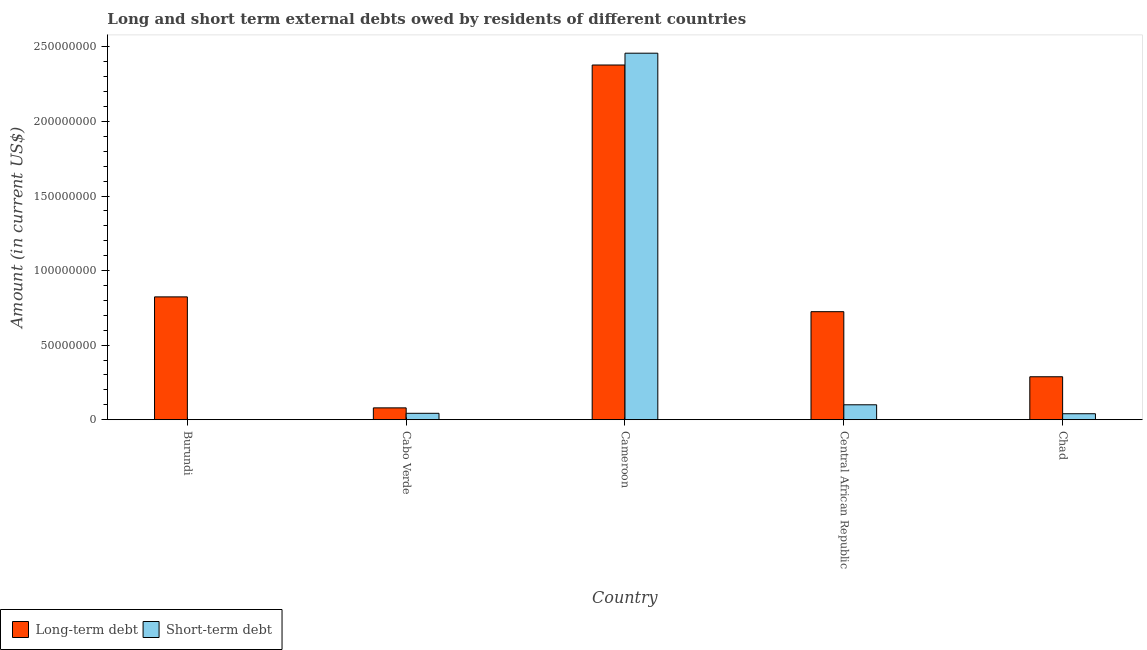How many different coloured bars are there?
Offer a terse response. 2. Are the number of bars on each tick of the X-axis equal?
Give a very brief answer. No. What is the label of the 5th group of bars from the left?
Provide a succinct answer. Chad. In how many cases, is the number of bars for a given country not equal to the number of legend labels?
Your response must be concise. 1. What is the long-term debts owed by residents in Chad?
Provide a short and direct response. 2.88e+07. Across all countries, what is the maximum long-term debts owed by residents?
Offer a very short reply. 2.38e+08. Across all countries, what is the minimum long-term debts owed by residents?
Keep it short and to the point. 7.93e+06. In which country was the long-term debts owed by residents maximum?
Make the answer very short. Cameroon. What is the total long-term debts owed by residents in the graph?
Your answer should be very brief. 4.29e+08. What is the difference between the long-term debts owed by residents in Central African Republic and that in Chad?
Offer a terse response. 4.36e+07. What is the difference between the long-term debts owed by residents in Central African Republic and the short-term debts owed by residents in Cabo Verde?
Your response must be concise. 6.82e+07. What is the average long-term debts owed by residents per country?
Keep it short and to the point. 8.59e+07. What is the difference between the long-term debts owed by residents and short-term debts owed by residents in Cabo Verde?
Offer a very short reply. 3.64e+06. In how many countries, is the long-term debts owed by residents greater than 200000000 US$?
Give a very brief answer. 1. What is the ratio of the short-term debts owed by residents in Cabo Verde to that in Chad?
Give a very brief answer. 1.07. Is the long-term debts owed by residents in Burundi less than that in Chad?
Keep it short and to the point. No. Is the difference between the short-term debts owed by residents in Cabo Verde and Central African Republic greater than the difference between the long-term debts owed by residents in Cabo Verde and Central African Republic?
Keep it short and to the point. Yes. What is the difference between the highest and the second highest long-term debts owed by residents?
Provide a succinct answer. 1.56e+08. What is the difference between the highest and the lowest long-term debts owed by residents?
Make the answer very short. 2.30e+08. Is the sum of the long-term debts owed by residents in Central African Republic and Chad greater than the maximum short-term debts owed by residents across all countries?
Provide a short and direct response. No. How many bars are there?
Your response must be concise. 9. Are all the bars in the graph horizontal?
Your answer should be compact. No. Does the graph contain grids?
Give a very brief answer. No. Where does the legend appear in the graph?
Your answer should be compact. Bottom left. How are the legend labels stacked?
Your response must be concise. Horizontal. What is the title of the graph?
Make the answer very short. Long and short term external debts owed by residents of different countries. What is the Amount (in current US$) of Long-term debt in Burundi?
Provide a short and direct response. 8.24e+07. What is the Amount (in current US$) in Short-term debt in Burundi?
Provide a short and direct response. 0. What is the Amount (in current US$) in Long-term debt in Cabo Verde?
Your response must be concise. 7.93e+06. What is the Amount (in current US$) in Short-term debt in Cabo Verde?
Give a very brief answer. 4.29e+06. What is the Amount (in current US$) of Long-term debt in Cameroon?
Make the answer very short. 2.38e+08. What is the Amount (in current US$) in Short-term debt in Cameroon?
Offer a very short reply. 2.46e+08. What is the Amount (in current US$) of Long-term debt in Central African Republic?
Offer a terse response. 7.24e+07. What is the Amount (in current US$) of Short-term debt in Central African Republic?
Your answer should be compact. 1.00e+07. What is the Amount (in current US$) in Long-term debt in Chad?
Your answer should be very brief. 2.88e+07. What is the Amount (in current US$) of Short-term debt in Chad?
Make the answer very short. 4.00e+06. Across all countries, what is the maximum Amount (in current US$) in Long-term debt?
Give a very brief answer. 2.38e+08. Across all countries, what is the maximum Amount (in current US$) in Short-term debt?
Make the answer very short. 2.46e+08. Across all countries, what is the minimum Amount (in current US$) of Long-term debt?
Your response must be concise. 7.93e+06. Across all countries, what is the minimum Amount (in current US$) in Short-term debt?
Provide a succinct answer. 0. What is the total Amount (in current US$) in Long-term debt in the graph?
Make the answer very short. 4.29e+08. What is the total Amount (in current US$) in Short-term debt in the graph?
Keep it short and to the point. 2.64e+08. What is the difference between the Amount (in current US$) of Long-term debt in Burundi and that in Cabo Verde?
Provide a succinct answer. 7.44e+07. What is the difference between the Amount (in current US$) of Long-term debt in Burundi and that in Cameroon?
Ensure brevity in your answer.  -1.56e+08. What is the difference between the Amount (in current US$) of Long-term debt in Burundi and that in Central African Republic?
Offer a very short reply. 9.93e+06. What is the difference between the Amount (in current US$) in Long-term debt in Burundi and that in Chad?
Give a very brief answer. 5.36e+07. What is the difference between the Amount (in current US$) in Long-term debt in Cabo Verde and that in Cameroon?
Ensure brevity in your answer.  -2.30e+08. What is the difference between the Amount (in current US$) in Short-term debt in Cabo Verde and that in Cameroon?
Ensure brevity in your answer.  -2.42e+08. What is the difference between the Amount (in current US$) of Long-term debt in Cabo Verde and that in Central African Republic?
Give a very brief answer. -6.45e+07. What is the difference between the Amount (in current US$) in Short-term debt in Cabo Verde and that in Central African Republic?
Keep it short and to the point. -5.71e+06. What is the difference between the Amount (in current US$) of Long-term debt in Cabo Verde and that in Chad?
Keep it short and to the point. -2.09e+07. What is the difference between the Amount (in current US$) in Long-term debt in Cameroon and that in Central African Republic?
Provide a short and direct response. 1.65e+08. What is the difference between the Amount (in current US$) in Short-term debt in Cameroon and that in Central African Republic?
Your response must be concise. 2.36e+08. What is the difference between the Amount (in current US$) of Long-term debt in Cameroon and that in Chad?
Give a very brief answer. 2.09e+08. What is the difference between the Amount (in current US$) in Short-term debt in Cameroon and that in Chad?
Make the answer very short. 2.42e+08. What is the difference between the Amount (in current US$) of Long-term debt in Central African Republic and that in Chad?
Offer a very short reply. 4.36e+07. What is the difference between the Amount (in current US$) in Short-term debt in Central African Republic and that in Chad?
Offer a terse response. 6.00e+06. What is the difference between the Amount (in current US$) of Long-term debt in Burundi and the Amount (in current US$) of Short-term debt in Cabo Verde?
Provide a short and direct response. 7.81e+07. What is the difference between the Amount (in current US$) of Long-term debt in Burundi and the Amount (in current US$) of Short-term debt in Cameroon?
Offer a very short reply. -1.63e+08. What is the difference between the Amount (in current US$) of Long-term debt in Burundi and the Amount (in current US$) of Short-term debt in Central African Republic?
Your response must be concise. 7.24e+07. What is the difference between the Amount (in current US$) in Long-term debt in Burundi and the Amount (in current US$) in Short-term debt in Chad?
Your response must be concise. 7.84e+07. What is the difference between the Amount (in current US$) in Long-term debt in Cabo Verde and the Amount (in current US$) in Short-term debt in Cameroon?
Your answer should be very brief. -2.38e+08. What is the difference between the Amount (in current US$) of Long-term debt in Cabo Verde and the Amount (in current US$) of Short-term debt in Central African Republic?
Your answer should be very brief. -2.07e+06. What is the difference between the Amount (in current US$) of Long-term debt in Cabo Verde and the Amount (in current US$) of Short-term debt in Chad?
Make the answer very short. 3.93e+06. What is the difference between the Amount (in current US$) of Long-term debt in Cameroon and the Amount (in current US$) of Short-term debt in Central African Republic?
Offer a terse response. 2.28e+08. What is the difference between the Amount (in current US$) of Long-term debt in Cameroon and the Amount (in current US$) of Short-term debt in Chad?
Make the answer very short. 2.34e+08. What is the difference between the Amount (in current US$) of Long-term debt in Central African Republic and the Amount (in current US$) of Short-term debt in Chad?
Offer a terse response. 6.84e+07. What is the average Amount (in current US$) of Long-term debt per country?
Offer a terse response. 8.59e+07. What is the average Amount (in current US$) in Short-term debt per country?
Your answer should be compact. 5.28e+07. What is the difference between the Amount (in current US$) in Long-term debt and Amount (in current US$) in Short-term debt in Cabo Verde?
Offer a very short reply. 3.64e+06. What is the difference between the Amount (in current US$) in Long-term debt and Amount (in current US$) in Short-term debt in Cameroon?
Provide a succinct answer. -7.92e+06. What is the difference between the Amount (in current US$) in Long-term debt and Amount (in current US$) in Short-term debt in Central African Republic?
Your answer should be very brief. 6.24e+07. What is the difference between the Amount (in current US$) in Long-term debt and Amount (in current US$) in Short-term debt in Chad?
Your answer should be compact. 2.48e+07. What is the ratio of the Amount (in current US$) in Long-term debt in Burundi to that in Cabo Verde?
Keep it short and to the point. 10.38. What is the ratio of the Amount (in current US$) in Long-term debt in Burundi to that in Cameroon?
Offer a terse response. 0.35. What is the ratio of the Amount (in current US$) of Long-term debt in Burundi to that in Central African Republic?
Provide a succinct answer. 1.14. What is the ratio of the Amount (in current US$) in Long-term debt in Burundi to that in Chad?
Offer a very short reply. 2.86. What is the ratio of the Amount (in current US$) in Long-term debt in Cabo Verde to that in Cameroon?
Offer a terse response. 0.03. What is the ratio of the Amount (in current US$) of Short-term debt in Cabo Verde to that in Cameroon?
Your answer should be very brief. 0.02. What is the ratio of the Amount (in current US$) of Long-term debt in Cabo Verde to that in Central African Republic?
Offer a very short reply. 0.11. What is the ratio of the Amount (in current US$) of Short-term debt in Cabo Verde to that in Central African Republic?
Offer a very short reply. 0.43. What is the ratio of the Amount (in current US$) of Long-term debt in Cabo Verde to that in Chad?
Your answer should be very brief. 0.28. What is the ratio of the Amount (in current US$) of Short-term debt in Cabo Verde to that in Chad?
Provide a short and direct response. 1.07. What is the ratio of the Amount (in current US$) in Long-term debt in Cameroon to that in Central African Republic?
Your response must be concise. 3.28. What is the ratio of the Amount (in current US$) in Short-term debt in Cameroon to that in Central African Republic?
Offer a very short reply. 24.58. What is the ratio of the Amount (in current US$) in Long-term debt in Cameroon to that in Chad?
Your answer should be compact. 8.26. What is the ratio of the Amount (in current US$) in Short-term debt in Cameroon to that in Chad?
Your answer should be very brief. 61.45. What is the ratio of the Amount (in current US$) in Long-term debt in Central African Republic to that in Chad?
Your answer should be very brief. 2.52. What is the ratio of the Amount (in current US$) in Short-term debt in Central African Republic to that in Chad?
Provide a succinct answer. 2.5. What is the difference between the highest and the second highest Amount (in current US$) in Long-term debt?
Provide a succinct answer. 1.56e+08. What is the difference between the highest and the second highest Amount (in current US$) in Short-term debt?
Your answer should be very brief. 2.36e+08. What is the difference between the highest and the lowest Amount (in current US$) of Long-term debt?
Your answer should be compact. 2.30e+08. What is the difference between the highest and the lowest Amount (in current US$) in Short-term debt?
Your response must be concise. 2.46e+08. 